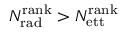<formula> <loc_0><loc_0><loc_500><loc_500>N _ { r a d } ^ { r a n k } > N _ { e t t } ^ { r a n k }</formula> 